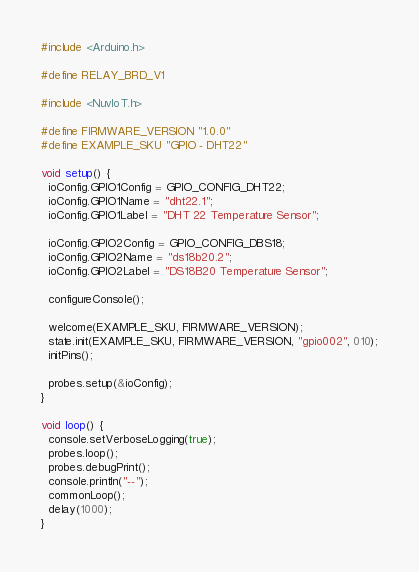<code> <loc_0><loc_0><loc_500><loc_500><_C++_>#include <Arduino.h>

#define RELAY_BRD_V1

#include <NuvIoT.h>

#define FIRMWARE_VERSION "1.0.0"
#define EXAMPLE_SKU "GPIO - DHT22"

void setup() {
  ioConfig.GPIO1Config = GPIO_CONFIG_DHT22;
  ioConfig.GPIO1Name = "dht22.1";
  ioConfig.GPIO1Label = "DHT 22 Temperature Sensor";

  ioConfig.GPIO2Config = GPIO_CONFIG_DBS18;
  ioConfig.GPIO2Name = "ds18b20.2";
  ioConfig.GPIO2Label = "DS18B20 Temperature Sensor";
  
  configureConsole();
  
  welcome(EXAMPLE_SKU, FIRMWARE_VERSION);
  state.init(EXAMPLE_SKU, FIRMWARE_VERSION, "gpio002", 010);
  initPins();

  probes.setup(&ioConfig);
}

void loop() {
  console.setVerboseLogging(true);
  probes.loop();
  probes.debugPrint();
  console.println("--");
  commonLoop();
  delay(1000);
}</code> 